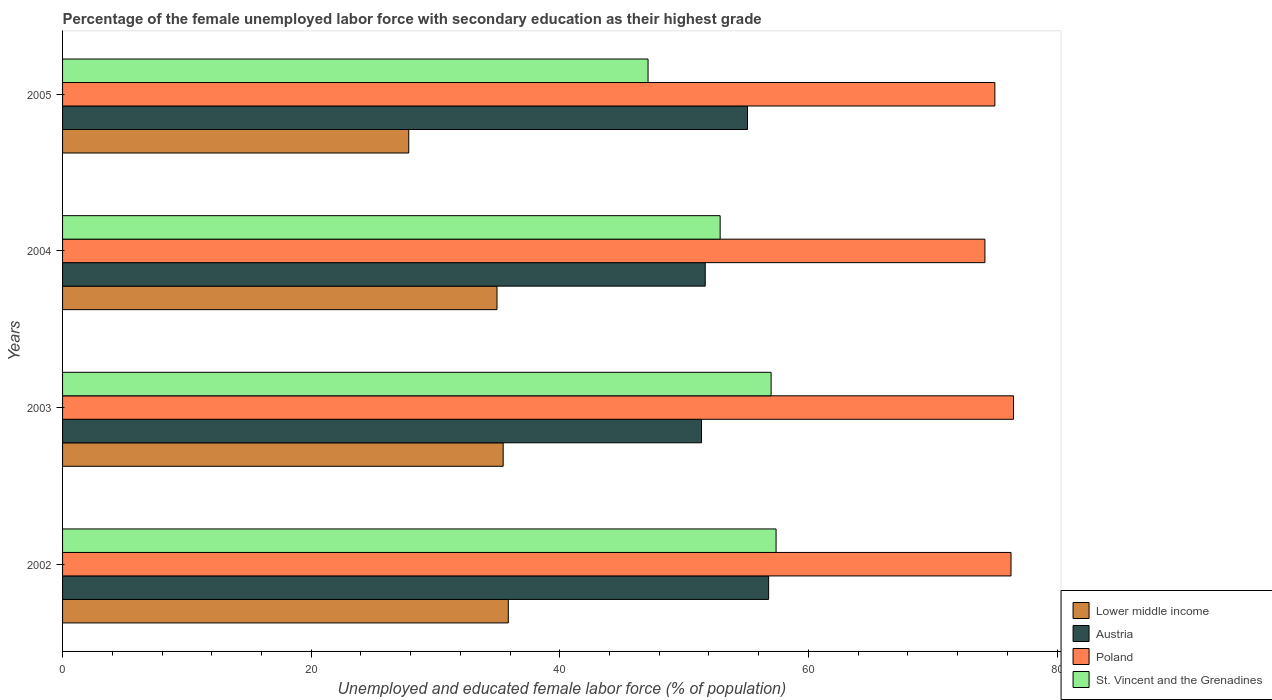How many different coloured bars are there?
Keep it short and to the point. 4. How many groups of bars are there?
Your answer should be compact. 4. Are the number of bars per tick equal to the number of legend labels?
Your answer should be very brief. Yes. How many bars are there on the 2nd tick from the top?
Your response must be concise. 4. What is the percentage of the unemployed female labor force with secondary education in Austria in 2003?
Make the answer very short. 51.4. Across all years, what is the maximum percentage of the unemployed female labor force with secondary education in Poland?
Give a very brief answer. 76.5. Across all years, what is the minimum percentage of the unemployed female labor force with secondary education in Lower middle income?
Give a very brief answer. 27.85. In which year was the percentage of the unemployed female labor force with secondary education in Lower middle income minimum?
Your response must be concise. 2005. What is the total percentage of the unemployed female labor force with secondary education in Poland in the graph?
Offer a terse response. 302. What is the difference between the percentage of the unemployed female labor force with secondary education in Poland in 2003 and that in 2004?
Provide a succinct answer. 2.3. What is the difference between the percentage of the unemployed female labor force with secondary education in Austria in 2004 and the percentage of the unemployed female labor force with secondary education in St. Vincent and the Grenadines in 2003?
Keep it short and to the point. -5.3. What is the average percentage of the unemployed female labor force with secondary education in Austria per year?
Provide a short and direct response. 53.75. In the year 2004, what is the difference between the percentage of the unemployed female labor force with secondary education in St. Vincent and the Grenadines and percentage of the unemployed female labor force with secondary education in Austria?
Provide a short and direct response. 1.2. In how many years, is the percentage of the unemployed female labor force with secondary education in Austria greater than 32 %?
Make the answer very short. 4. What is the ratio of the percentage of the unemployed female labor force with secondary education in St. Vincent and the Grenadines in 2002 to that in 2005?
Provide a short and direct response. 1.22. Is the difference between the percentage of the unemployed female labor force with secondary education in St. Vincent and the Grenadines in 2002 and 2005 greater than the difference between the percentage of the unemployed female labor force with secondary education in Austria in 2002 and 2005?
Keep it short and to the point. Yes. What is the difference between the highest and the second highest percentage of the unemployed female labor force with secondary education in Lower middle income?
Make the answer very short. 0.41. What is the difference between the highest and the lowest percentage of the unemployed female labor force with secondary education in Lower middle income?
Your answer should be compact. 8.01. In how many years, is the percentage of the unemployed female labor force with secondary education in Austria greater than the average percentage of the unemployed female labor force with secondary education in Austria taken over all years?
Provide a short and direct response. 2. Is the sum of the percentage of the unemployed female labor force with secondary education in Poland in 2003 and 2005 greater than the maximum percentage of the unemployed female labor force with secondary education in Austria across all years?
Provide a short and direct response. Yes. What does the 4th bar from the top in 2004 represents?
Make the answer very short. Lower middle income. What does the 4th bar from the bottom in 2002 represents?
Your answer should be compact. St. Vincent and the Grenadines. Are all the bars in the graph horizontal?
Make the answer very short. Yes. How many years are there in the graph?
Keep it short and to the point. 4. What is the difference between two consecutive major ticks on the X-axis?
Ensure brevity in your answer.  20. Are the values on the major ticks of X-axis written in scientific E-notation?
Offer a very short reply. No. Does the graph contain any zero values?
Your answer should be compact. No. Does the graph contain grids?
Ensure brevity in your answer.  No. Where does the legend appear in the graph?
Provide a short and direct response. Bottom right. What is the title of the graph?
Keep it short and to the point. Percentage of the female unemployed labor force with secondary education as their highest grade. Does "Tajikistan" appear as one of the legend labels in the graph?
Keep it short and to the point. No. What is the label or title of the X-axis?
Provide a succinct answer. Unemployed and educated female labor force (% of population). What is the label or title of the Y-axis?
Offer a very short reply. Years. What is the Unemployed and educated female labor force (% of population) of Lower middle income in 2002?
Ensure brevity in your answer.  35.86. What is the Unemployed and educated female labor force (% of population) in Austria in 2002?
Keep it short and to the point. 56.8. What is the Unemployed and educated female labor force (% of population) in Poland in 2002?
Provide a succinct answer. 76.3. What is the Unemployed and educated female labor force (% of population) in St. Vincent and the Grenadines in 2002?
Offer a very short reply. 57.4. What is the Unemployed and educated female labor force (% of population) of Lower middle income in 2003?
Provide a succinct answer. 35.45. What is the Unemployed and educated female labor force (% of population) of Austria in 2003?
Offer a terse response. 51.4. What is the Unemployed and educated female labor force (% of population) in Poland in 2003?
Ensure brevity in your answer.  76.5. What is the Unemployed and educated female labor force (% of population) of St. Vincent and the Grenadines in 2003?
Give a very brief answer. 57. What is the Unemployed and educated female labor force (% of population) of Lower middle income in 2004?
Provide a short and direct response. 34.95. What is the Unemployed and educated female labor force (% of population) of Austria in 2004?
Provide a short and direct response. 51.7. What is the Unemployed and educated female labor force (% of population) of Poland in 2004?
Keep it short and to the point. 74.2. What is the Unemployed and educated female labor force (% of population) in St. Vincent and the Grenadines in 2004?
Your response must be concise. 52.9. What is the Unemployed and educated female labor force (% of population) in Lower middle income in 2005?
Offer a terse response. 27.85. What is the Unemployed and educated female labor force (% of population) of Austria in 2005?
Your response must be concise. 55.1. What is the Unemployed and educated female labor force (% of population) of St. Vincent and the Grenadines in 2005?
Make the answer very short. 47.1. Across all years, what is the maximum Unemployed and educated female labor force (% of population) in Lower middle income?
Your answer should be compact. 35.86. Across all years, what is the maximum Unemployed and educated female labor force (% of population) in Austria?
Give a very brief answer. 56.8. Across all years, what is the maximum Unemployed and educated female labor force (% of population) of Poland?
Give a very brief answer. 76.5. Across all years, what is the maximum Unemployed and educated female labor force (% of population) in St. Vincent and the Grenadines?
Keep it short and to the point. 57.4. Across all years, what is the minimum Unemployed and educated female labor force (% of population) of Lower middle income?
Offer a terse response. 27.85. Across all years, what is the minimum Unemployed and educated female labor force (% of population) of Austria?
Provide a short and direct response. 51.4. Across all years, what is the minimum Unemployed and educated female labor force (% of population) of Poland?
Keep it short and to the point. 74.2. Across all years, what is the minimum Unemployed and educated female labor force (% of population) of St. Vincent and the Grenadines?
Give a very brief answer. 47.1. What is the total Unemployed and educated female labor force (% of population) in Lower middle income in the graph?
Make the answer very short. 134.1. What is the total Unemployed and educated female labor force (% of population) in Austria in the graph?
Provide a succinct answer. 215. What is the total Unemployed and educated female labor force (% of population) of Poland in the graph?
Give a very brief answer. 302. What is the total Unemployed and educated female labor force (% of population) in St. Vincent and the Grenadines in the graph?
Offer a terse response. 214.4. What is the difference between the Unemployed and educated female labor force (% of population) in Lower middle income in 2002 and that in 2003?
Keep it short and to the point. 0.41. What is the difference between the Unemployed and educated female labor force (% of population) of Lower middle income in 2002 and that in 2004?
Give a very brief answer. 0.91. What is the difference between the Unemployed and educated female labor force (% of population) in Lower middle income in 2002 and that in 2005?
Make the answer very short. 8.01. What is the difference between the Unemployed and educated female labor force (% of population) in Austria in 2002 and that in 2005?
Offer a terse response. 1.7. What is the difference between the Unemployed and educated female labor force (% of population) in Poland in 2002 and that in 2005?
Give a very brief answer. 1.3. What is the difference between the Unemployed and educated female labor force (% of population) of Lower middle income in 2003 and that in 2004?
Keep it short and to the point. 0.5. What is the difference between the Unemployed and educated female labor force (% of population) of Austria in 2003 and that in 2004?
Provide a short and direct response. -0.3. What is the difference between the Unemployed and educated female labor force (% of population) in Poland in 2003 and that in 2004?
Ensure brevity in your answer.  2.3. What is the difference between the Unemployed and educated female labor force (% of population) of St. Vincent and the Grenadines in 2003 and that in 2004?
Make the answer very short. 4.1. What is the difference between the Unemployed and educated female labor force (% of population) of Lower middle income in 2003 and that in 2005?
Ensure brevity in your answer.  7.6. What is the difference between the Unemployed and educated female labor force (% of population) of Austria in 2003 and that in 2005?
Offer a terse response. -3.7. What is the difference between the Unemployed and educated female labor force (% of population) of Lower middle income in 2004 and that in 2005?
Give a very brief answer. 7.1. What is the difference between the Unemployed and educated female labor force (% of population) of Austria in 2004 and that in 2005?
Provide a short and direct response. -3.4. What is the difference between the Unemployed and educated female labor force (% of population) in St. Vincent and the Grenadines in 2004 and that in 2005?
Offer a very short reply. 5.8. What is the difference between the Unemployed and educated female labor force (% of population) in Lower middle income in 2002 and the Unemployed and educated female labor force (% of population) in Austria in 2003?
Offer a terse response. -15.54. What is the difference between the Unemployed and educated female labor force (% of population) of Lower middle income in 2002 and the Unemployed and educated female labor force (% of population) of Poland in 2003?
Your response must be concise. -40.64. What is the difference between the Unemployed and educated female labor force (% of population) of Lower middle income in 2002 and the Unemployed and educated female labor force (% of population) of St. Vincent and the Grenadines in 2003?
Give a very brief answer. -21.14. What is the difference between the Unemployed and educated female labor force (% of population) of Austria in 2002 and the Unemployed and educated female labor force (% of population) of Poland in 2003?
Your answer should be compact. -19.7. What is the difference between the Unemployed and educated female labor force (% of population) of Poland in 2002 and the Unemployed and educated female labor force (% of population) of St. Vincent and the Grenadines in 2003?
Offer a very short reply. 19.3. What is the difference between the Unemployed and educated female labor force (% of population) of Lower middle income in 2002 and the Unemployed and educated female labor force (% of population) of Austria in 2004?
Provide a short and direct response. -15.84. What is the difference between the Unemployed and educated female labor force (% of population) in Lower middle income in 2002 and the Unemployed and educated female labor force (% of population) in Poland in 2004?
Make the answer very short. -38.34. What is the difference between the Unemployed and educated female labor force (% of population) in Lower middle income in 2002 and the Unemployed and educated female labor force (% of population) in St. Vincent and the Grenadines in 2004?
Your response must be concise. -17.04. What is the difference between the Unemployed and educated female labor force (% of population) in Austria in 2002 and the Unemployed and educated female labor force (% of population) in Poland in 2004?
Ensure brevity in your answer.  -17.4. What is the difference between the Unemployed and educated female labor force (% of population) of Austria in 2002 and the Unemployed and educated female labor force (% of population) of St. Vincent and the Grenadines in 2004?
Provide a succinct answer. 3.9. What is the difference between the Unemployed and educated female labor force (% of population) of Poland in 2002 and the Unemployed and educated female labor force (% of population) of St. Vincent and the Grenadines in 2004?
Your response must be concise. 23.4. What is the difference between the Unemployed and educated female labor force (% of population) of Lower middle income in 2002 and the Unemployed and educated female labor force (% of population) of Austria in 2005?
Your answer should be very brief. -19.24. What is the difference between the Unemployed and educated female labor force (% of population) in Lower middle income in 2002 and the Unemployed and educated female labor force (% of population) in Poland in 2005?
Offer a very short reply. -39.14. What is the difference between the Unemployed and educated female labor force (% of population) of Lower middle income in 2002 and the Unemployed and educated female labor force (% of population) of St. Vincent and the Grenadines in 2005?
Make the answer very short. -11.24. What is the difference between the Unemployed and educated female labor force (% of population) of Austria in 2002 and the Unemployed and educated female labor force (% of population) of Poland in 2005?
Your answer should be very brief. -18.2. What is the difference between the Unemployed and educated female labor force (% of population) of Poland in 2002 and the Unemployed and educated female labor force (% of population) of St. Vincent and the Grenadines in 2005?
Your response must be concise. 29.2. What is the difference between the Unemployed and educated female labor force (% of population) in Lower middle income in 2003 and the Unemployed and educated female labor force (% of population) in Austria in 2004?
Your answer should be very brief. -16.25. What is the difference between the Unemployed and educated female labor force (% of population) of Lower middle income in 2003 and the Unemployed and educated female labor force (% of population) of Poland in 2004?
Your answer should be very brief. -38.75. What is the difference between the Unemployed and educated female labor force (% of population) of Lower middle income in 2003 and the Unemployed and educated female labor force (% of population) of St. Vincent and the Grenadines in 2004?
Your answer should be very brief. -17.45. What is the difference between the Unemployed and educated female labor force (% of population) in Austria in 2003 and the Unemployed and educated female labor force (% of population) in Poland in 2004?
Your answer should be very brief. -22.8. What is the difference between the Unemployed and educated female labor force (% of population) of Austria in 2003 and the Unemployed and educated female labor force (% of population) of St. Vincent and the Grenadines in 2004?
Make the answer very short. -1.5. What is the difference between the Unemployed and educated female labor force (% of population) of Poland in 2003 and the Unemployed and educated female labor force (% of population) of St. Vincent and the Grenadines in 2004?
Provide a short and direct response. 23.6. What is the difference between the Unemployed and educated female labor force (% of population) in Lower middle income in 2003 and the Unemployed and educated female labor force (% of population) in Austria in 2005?
Provide a short and direct response. -19.65. What is the difference between the Unemployed and educated female labor force (% of population) in Lower middle income in 2003 and the Unemployed and educated female labor force (% of population) in Poland in 2005?
Provide a short and direct response. -39.55. What is the difference between the Unemployed and educated female labor force (% of population) in Lower middle income in 2003 and the Unemployed and educated female labor force (% of population) in St. Vincent and the Grenadines in 2005?
Provide a succinct answer. -11.65. What is the difference between the Unemployed and educated female labor force (% of population) of Austria in 2003 and the Unemployed and educated female labor force (% of population) of Poland in 2005?
Give a very brief answer. -23.6. What is the difference between the Unemployed and educated female labor force (% of population) of Austria in 2003 and the Unemployed and educated female labor force (% of population) of St. Vincent and the Grenadines in 2005?
Provide a succinct answer. 4.3. What is the difference between the Unemployed and educated female labor force (% of population) of Poland in 2003 and the Unemployed and educated female labor force (% of population) of St. Vincent and the Grenadines in 2005?
Offer a very short reply. 29.4. What is the difference between the Unemployed and educated female labor force (% of population) of Lower middle income in 2004 and the Unemployed and educated female labor force (% of population) of Austria in 2005?
Your response must be concise. -20.15. What is the difference between the Unemployed and educated female labor force (% of population) of Lower middle income in 2004 and the Unemployed and educated female labor force (% of population) of Poland in 2005?
Keep it short and to the point. -40.05. What is the difference between the Unemployed and educated female labor force (% of population) in Lower middle income in 2004 and the Unemployed and educated female labor force (% of population) in St. Vincent and the Grenadines in 2005?
Ensure brevity in your answer.  -12.15. What is the difference between the Unemployed and educated female labor force (% of population) in Austria in 2004 and the Unemployed and educated female labor force (% of population) in Poland in 2005?
Provide a short and direct response. -23.3. What is the difference between the Unemployed and educated female labor force (% of population) of Austria in 2004 and the Unemployed and educated female labor force (% of population) of St. Vincent and the Grenadines in 2005?
Ensure brevity in your answer.  4.6. What is the difference between the Unemployed and educated female labor force (% of population) in Poland in 2004 and the Unemployed and educated female labor force (% of population) in St. Vincent and the Grenadines in 2005?
Offer a very short reply. 27.1. What is the average Unemployed and educated female labor force (% of population) of Lower middle income per year?
Ensure brevity in your answer.  33.53. What is the average Unemployed and educated female labor force (% of population) in Austria per year?
Your response must be concise. 53.75. What is the average Unemployed and educated female labor force (% of population) in Poland per year?
Your answer should be compact. 75.5. What is the average Unemployed and educated female labor force (% of population) of St. Vincent and the Grenadines per year?
Your response must be concise. 53.6. In the year 2002, what is the difference between the Unemployed and educated female labor force (% of population) in Lower middle income and Unemployed and educated female labor force (% of population) in Austria?
Offer a terse response. -20.94. In the year 2002, what is the difference between the Unemployed and educated female labor force (% of population) of Lower middle income and Unemployed and educated female labor force (% of population) of Poland?
Offer a very short reply. -40.44. In the year 2002, what is the difference between the Unemployed and educated female labor force (% of population) of Lower middle income and Unemployed and educated female labor force (% of population) of St. Vincent and the Grenadines?
Make the answer very short. -21.54. In the year 2002, what is the difference between the Unemployed and educated female labor force (% of population) of Austria and Unemployed and educated female labor force (% of population) of Poland?
Your answer should be very brief. -19.5. In the year 2002, what is the difference between the Unemployed and educated female labor force (% of population) of Poland and Unemployed and educated female labor force (% of population) of St. Vincent and the Grenadines?
Provide a short and direct response. 18.9. In the year 2003, what is the difference between the Unemployed and educated female labor force (% of population) of Lower middle income and Unemployed and educated female labor force (% of population) of Austria?
Provide a succinct answer. -15.95. In the year 2003, what is the difference between the Unemployed and educated female labor force (% of population) in Lower middle income and Unemployed and educated female labor force (% of population) in Poland?
Your response must be concise. -41.05. In the year 2003, what is the difference between the Unemployed and educated female labor force (% of population) in Lower middle income and Unemployed and educated female labor force (% of population) in St. Vincent and the Grenadines?
Your answer should be compact. -21.55. In the year 2003, what is the difference between the Unemployed and educated female labor force (% of population) of Austria and Unemployed and educated female labor force (% of population) of Poland?
Your response must be concise. -25.1. In the year 2004, what is the difference between the Unemployed and educated female labor force (% of population) of Lower middle income and Unemployed and educated female labor force (% of population) of Austria?
Keep it short and to the point. -16.75. In the year 2004, what is the difference between the Unemployed and educated female labor force (% of population) of Lower middle income and Unemployed and educated female labor force (% of population) of Poland?
Your answer should be very brief. -39.25. In the year 2004, what is the difference between the Unemployed and educated female labor force (% of population) in Lower middle income and Unemployed and educated female labor force (% of population) in St. Vincent and the Grenadines?
Provide a succinct answer. -17.95. In the year 2004, what is the difference between the Unemployed and educated female labor force (% of population) in Austria and Unemployed and educated female labor force (% of population) in Poland?
Ensure brevity in your answer.  -22.5. In the year 2004, what is the difference between the Unemployed and educated female labor force (% of population) of Poland and Unemployed and educated female labor force (% of population) of St. Vincent and the Grenadines?
Offer a terse response. 21.3. In the year 2005, what is the difference between the Unemployed and educated female labor force (% of population) of Lower middle income and Unemployed and educated female labor force (% of population) of Austria?
Provide a short and direct response. -27.25. In the year 2005, what is the difference between the Unemployed and educated female labor force (% of population) in Lower middle income and Unemployed and educated female labor force (% of population) in Poland?
Provide a short and direct response. -47.15. In the year 2005, what is the difference between the Unemployed and educated female labor force (% of population) of Lower middle income and Unemployed and educated female labor force (% of population) of St. Vincent and the Grenadines?
Keep it short and to the point. -19.25. In the year 2005, what is the difference between the Unemployed and educated female labor force (% of population) in Austria and Unemployed and educated female labor force (% of population) in Poland?
Offer a very short reply. -19.9. In the year 2005, what is the difference between the Unemployed and educated female labor force (% of population) in Poland and Unemployed and educated female labor force (% of population) in St. Vincent and the Grenadines?
Provide a short and direct response. 27.9. What is the ratio of the Unemployed and educated female labor force (% of population) in Lower middle income in 2002 to that in 2003?
Ensure brevity in your answer.  1.01. What is the ratio of the Unemployed and educated female labor force (% of population) in Austria in 2002 to that in 2003?
Make the answer very short. 1.11. What is the ratio of the Unemployed and educated female labor force (% of population) of Poland in 2002 to that in 2003?
Your answer should be very brief. 1. What is the ratio of the Unemployed and educated female labor force (% of population) in Lower middle income in 2002 to that in 2004?
Provide a short and direct response. 1.03. What is the ratio of the Unemployed and educated female labor force (% of population) of Austria in 2002 to that in 2004?
Make the answer very short. 1.1. What is the ratio of the Unemployed and educated female labor force (% of population) in Poland in 2002 to that in 2004?
Provide a short and direct response. 1.03. What is the ratio of the Unemployed and educated female labor force (% of population) in St. Vincent and the Grenadines in 2002 to that in 2004?
Your response must be concise. 1.09. What is the ratio of the Unemployed and educated female labor force (% of population) in Lower middle income in 2002 to that in 2005?
Your answer should be very brief. 1.29. What is the ratio of the Unemployed and educated female labor force (% of population) in Austria in 2002 to that in 2005?
Provide a short and direct response. 1.03. What is the ratio of the Unemployed and educated female labor force (% of population) in Poland in 2002 to that in 2005?
Offer a terse response. 1.02. What is the ratio of the Unemployed and educated female labor force (% of population) of St. Vincent and the Grenadines in 2002 to that in 2005?
Your response must be concise. 1.22. What is the ratio of the Unemployed and educated female labor force (% of population) in Lower middle income in 2003 to that in 2004?
Give a very brief answer. 1.01. What is the ratio of the Unemployed and educated female labor force (% of population) in Poland in 2003 to that in 2004?
Your answer should be compact. 1.03. What is the ratio of the Unemployed and educated female labor force (% of population) of St. Vincent and the Grenadines in 2003 to that in 2004?
Ensure brevity in your answer.  1.08. What is the ratio of the Unemployed and educated female labor force (% of population) of Lower middle income in 2003 to that in 2005?
Your answer should be compact. 1.27. What is the ratio of the Unemployed and educated female labor force (% of population) of Austria in 2003 to that in 2005?
Your response must be concise. 0.93. What is the ratio of the Unemployed and educated female labor force (% of population) in Poland in 2003 to that in 2005?
Ensure brevity in your answer.  1.02. What is the ratio of the Unemployed and educated female labor force (% of population) of St. Vincent and the Grenadines in 2003 to that in 2005?
Your response must be concise. 1.21. What is the ratio of the Unemployed and educated female labor force (% of population) of Lower middle income in 2004 to that in 2005?
Give a very brief answer. 1.25. What is the ratio of the Unemployed and educated female labor force (% of population) of Austria in 2004 to that in 2005?
Provide a short and direct response. 0.94. What is the ratio of the Unemployed and educated female labor force (% of population) of Poland in 2004 to that in 2005?
Your response must be concise. 0.99. What is the ratio of the Unemployed and educated female labor force (% of population) of St. Vincent and the Grenadines in 2004 to that in 2005?
Your answer should be compact. 1.12. What is the difference between the highest and the second highest Unemployed and educated female labor force (% of population) in Lower middle income?
Provide a succinct answer. 0.41. What is the difference between the highest and the second highest Unemployed and educated female labor force (% of population) in Austria?
Ensure brevity in your answer.  1.7. What is the difference between the highest and the second highest Unemployed and educated female labor force (% of population) in Poland?
Provide a short and direct response. 0.2. What is the difference between the highest and the second highest Unemployed and educated female labor force (% of population) of St. Vincent and the Grenadines?
Make the answer very short. 0.4. What is the difference between the highest and the lowest Unemployed and educated female labor force (% of population) in Lower middle income?
Ensure brevity in your answer.  8.01. What is the difference between the highest and the lowest Unemployed and educated female labor force (% of population) in Poland?
Provide a short and direct response. 2.3. What is the difference between the highest and the lowest Unemployed and educated female labor force (% of population) in St. Vincent and the Grenadines?
Your answer should be very brief. 10.3. 